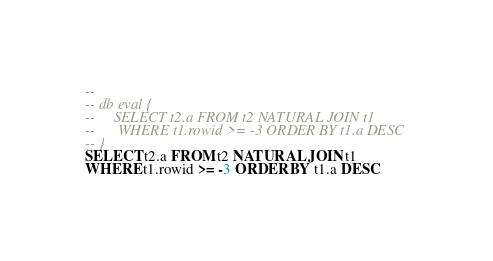<code> <loc_0><loc_0><loc_500><loc_500><_SQL_>-- 
-- db eval {
--     SELECT t2.a FROM t2 NATURAL JOIN t1
--      WHERE t1.rowid >= -3 ORDER BY t1.a DESC
-- }
SELECT t2.a FROM t2 NATURAL JOIN t1
WHERE t1.rowid >= -3 ORDER BY t1.a DESC</code> 